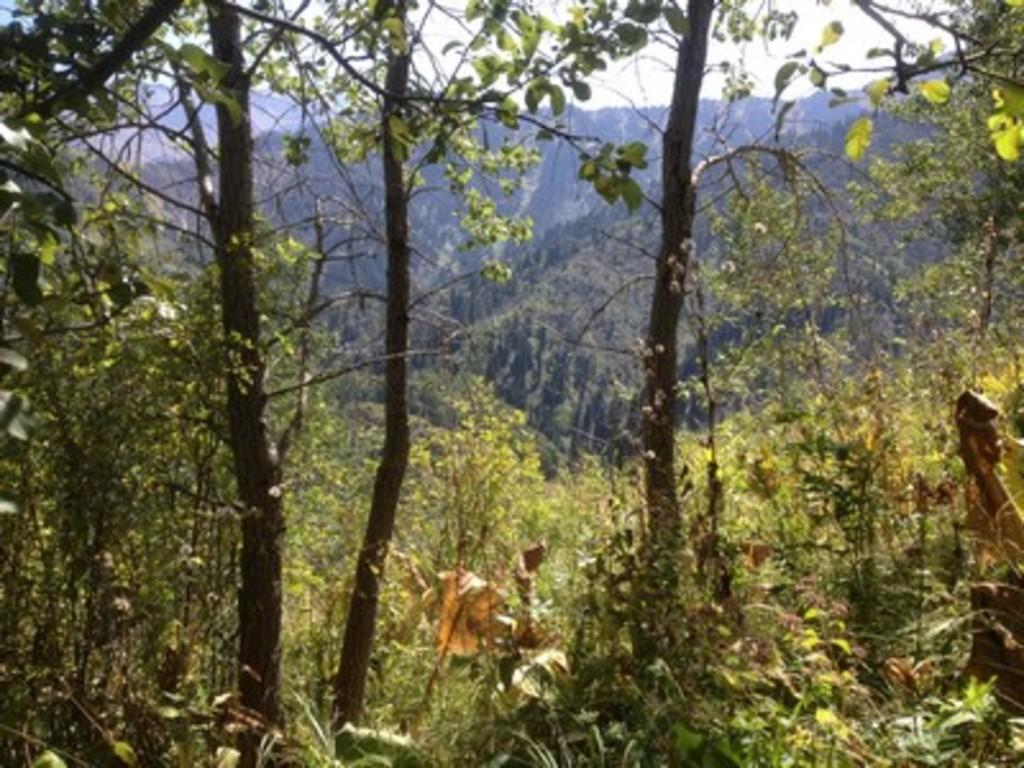What type of vegetation can be seen in the image? There are trees in the image. What is the condition of the sky in the image? The sky is cloudy in the image. Can you see any screws in the image? There are no screws visible in the image. What type of clouds can be seen in the image? The provided facts do not specify the type of clouds in the image, only that the sky is cloudy. 